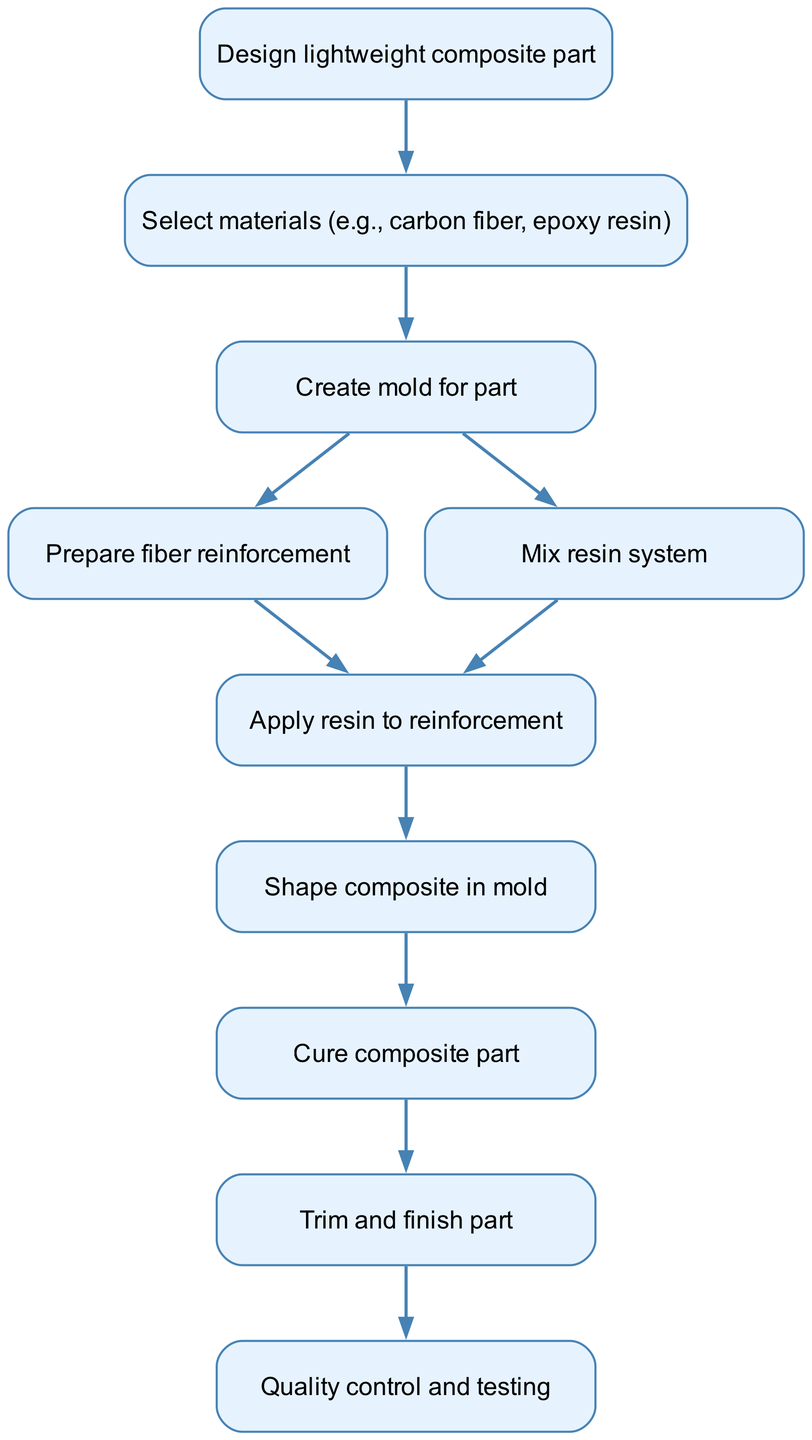What is the first step in the manufacturing workflow? The first step in the workflow is represented by the node labeled "Design lightweight composite part." This is the starting point of the process, as indicated in the diagram.
Answer: Design lightweight composite part How many nodes are in the diagram? To find the number of nodes, we count all the unique steps outlined in the diagram. There are ten distinct nodes listed.
Answer: 10 Which materials are selected after designing the part? After the design of the lightweight composite part, the next step according to the flow is to "Select materials (e.g., carbon fiber, epoxy resin)." This is the immediate process that follows design.
Answer: Select materials (e.g., carbon fiber, epoxy resin) What node comes after curing the composite part? After the node labeled "Cure composite part," the following node in the sequence is "Trim and finish part." This denotes the next stage after curing in the workflow.
Answer: Trim and finish part What are the last two steps in the manufacturing process? The last two steps in the manufacturing process are "Trim and finish part" followed by "Quality control and testing." These steps are at the end of the flowchart, showing the finalization and evaluation of the product.
Answer: Trim and finish part, Quality control and testing What step occurs simultaneously with shaping the composite? The diagram indicates that the steps "Apply resin to reinforcement" and "Shape composite in mold" follow the application of the resin and occur simultaneously after that.
Answer: Apply resin to reinforcement, Shape composite in mold What is the main purpose of the node labeled "Quality control and testing"? The purpose of the "Quality control and testing" node is to verify that the manufactured part meets the required standards and specifications before it is finalized and delivered.
Answer: Verify standards and specifications How many edges connect the nodes in this diagram? To find the number of edges, we count the connections between the nodes that represent the flow of the process. There are ten edges shown in the diagram linking the various steps.
Answer: 10 